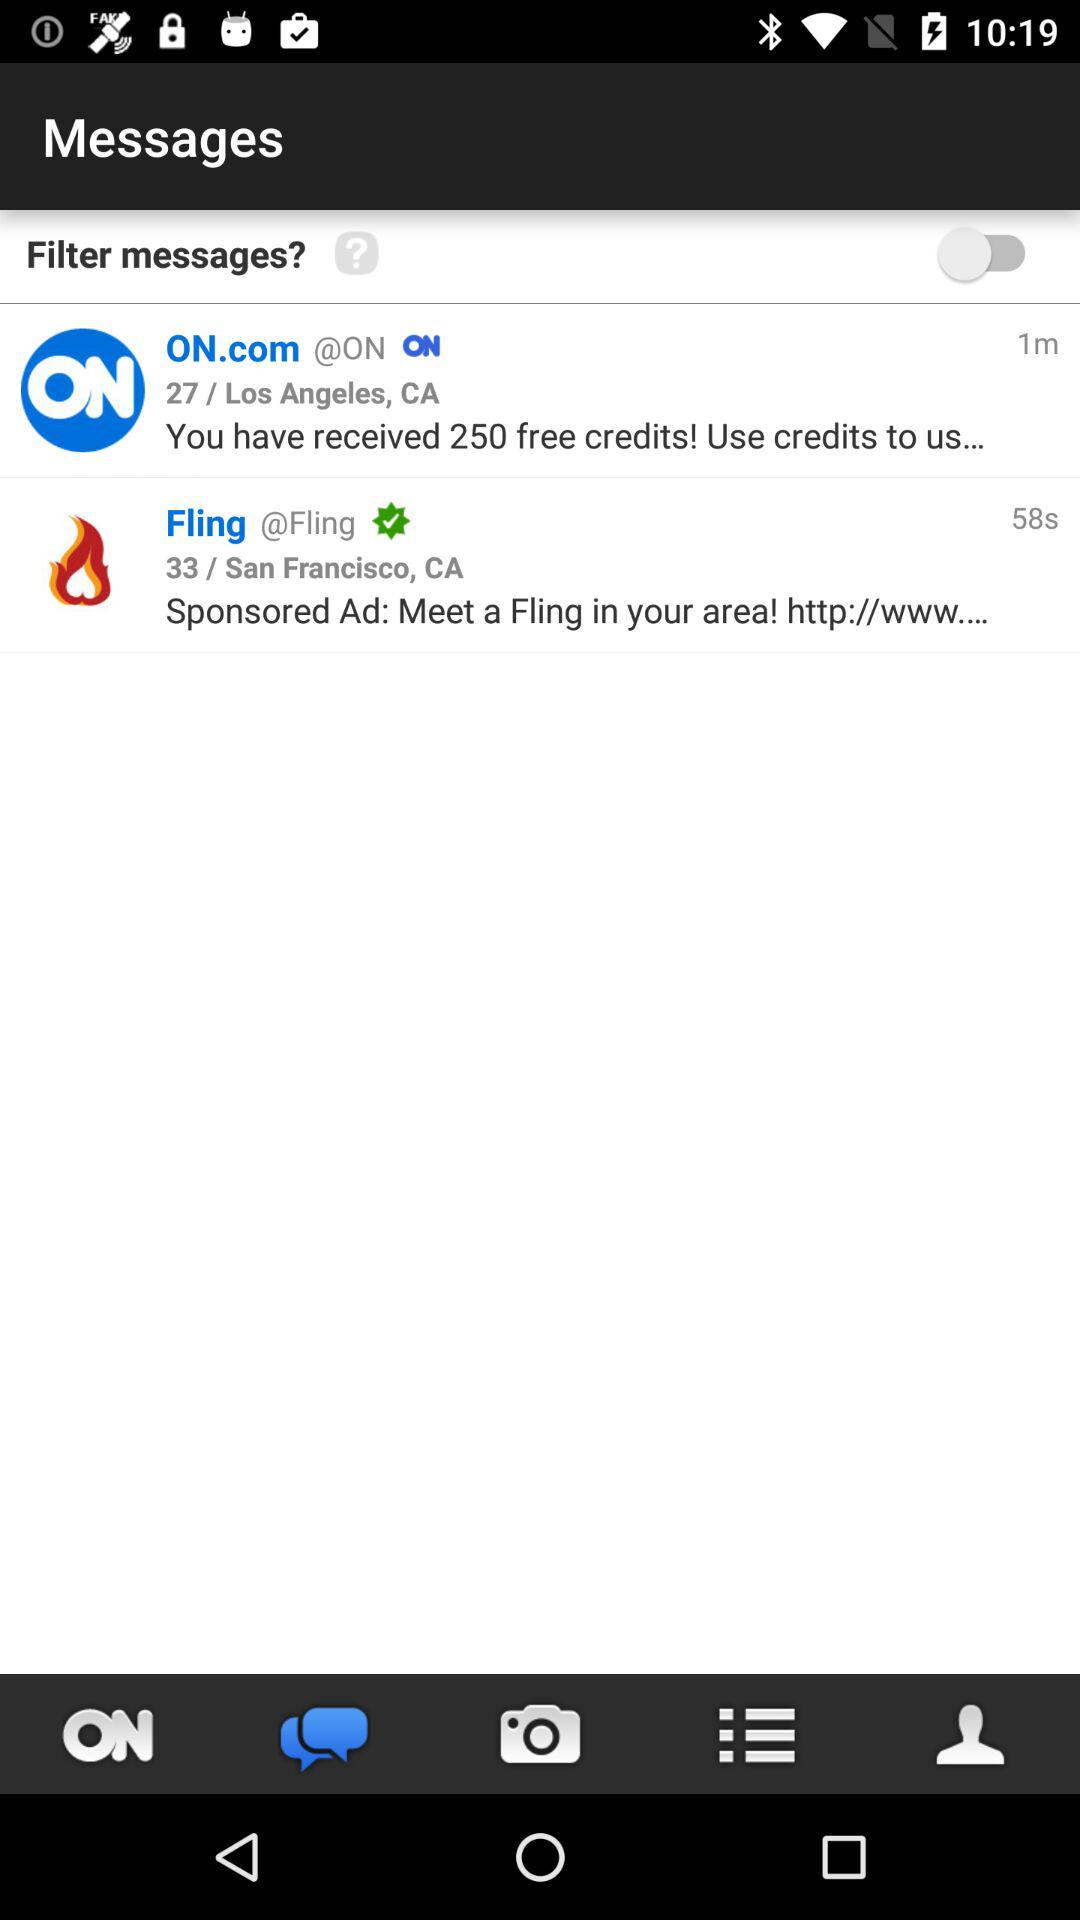How many messages have been received in total?
Answer the question using a single word or phrase. 2 